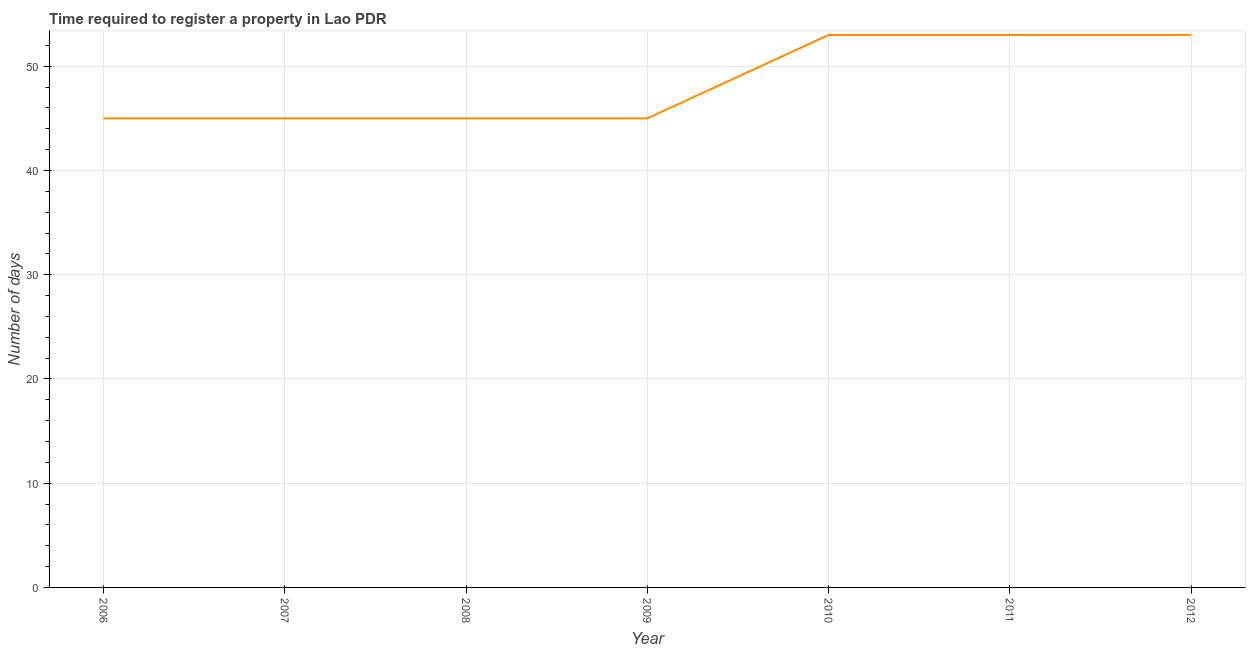What is the number of days required to register property in 2010?
Provide a succinct answer. 53. Across all years, what is the maximum number of days required to register property?
Give a very brief answer. 53. Across all years, what is the minimum number of days required to register property?
Provide a short and direct response. 45. In which year was the number of days required to register property minimum?
Provide a short and direct response. 2006. What is the sum of the number of days required to register property?
Provide a succinct answer. 339. What is the difference between the number of days required to register property in 2007 and 2012?
Your answer should be compact. -8. What is the average number of days required to register property per year?
Give a very brief answer. 48.43. What is the median number of days required to register property?
Provide a short and direct response. 45. In how many years, is the number of days required to register property greater than 48 days?
Make the answer very short. 3. What is the ratio of the number of days required to register property in 2006 to that in 2009?
Keep it short and to the point. 1. Is the difference between the number of days required to register property in 2007 and 2010 greater than the difference between any two years?
Ensure brevity in your answer.  Yes. What is the difference between the highest and the second highest number of days required to register property?
Your answer should be very brief. 0. Is the sum of the number of days required to register property in 2007 and 2008 greater than the maximum number of days required to register property across all years?
Offer a very short reply. Yes. What is the difference between the highest and the lowest number of days required to register property?
Keep it short and to the point. 8. In how many years, is the number of days required to register property greater than the average number of days required to register property taken over all years?
Your response must be concise. 3. Does the number of days required to register property monotonically increase over the years?
Ensure brevity in your answer.  No. What is the difference between two consecutive major ticks on the Y-axis?
Your response must be concise. 10. Are the values on the major ticks of Y-axis written in scientific E-notation?
Your response must be concise. No. Does the graph contain any zero values?
Provide a succinct answer. No. What is the title of the graph?
Offer a very short reply. Time required to register a property in Lao PDR. What is the label or title of the Y-axis?
Keep it short and to the point. Number of days. What is the Number of days of 2007?
Your answer should be compact. 45. What is the Number of days of 2010?
Provide a short and direct response. 53. What is the Number of days of 2011?
Offer a very short reply. 53. What is the difference between the Number of days in 2006 and 2010?
Your response must be concise. -8. What is the difference between the Number of days in 2006 and 2011?
Give a very brief answer. -8. What is the difference between the Number of days in 2007 and 2008?
Ensure brevity in your answer.  0. What is the difference between the Number of days in 2008 and 2009?
Keep it short and to the point. 0. What is the difference between the Number of days in 2008 and 2011?
Your answer should be very brief. -8. What is the difference between the Number of days in 2008 and 2012?
Keep it short and to the point. -8. What is the difference between the Number of days in 2010 and 2012?
Provide a short and direct response. 0. What is the difference between the Number of days in 2011 and 2012?
Give a very brief answer. 0. What is the ratio of the Number of days in 2006 to that in 2007?
Ensure brevity in your answer.  1. What is the ratio of the Number of days in 2006 to that in 2008?
Give a very brief answer. 1. What is the ratio of the Number of days in 2006 to that in 2009?
Offer a very short reply. 1. What is the ratio of the Number of days in 2006 to that in 2010?
Offer a terse response. 0.85. What is the ratio of the Number of days in 2006 to that in 2011?
Provide a succinct answer. 0.85. What is the ratio of the Number of days in 2006 to that in 2012?
Your answer should be very brief. 0.85. What is the ratio of the Number of days in 2007 to that in 2008?
Your answer should be compact. 1. What is the ratio of the Number of days in 2007 to that in 2010?
Your answer should be compact. 0.85. What is the ratio of the Number of days in 2007 to that in 2011?
Your response must be concise. 0.85. What is the ratio of the Number of days in 2007 to that in 2012?
Provide a succinct answer. 0.85. What is the ratio of the Number of days in 2008 to that in 2010?
Your response must be concise. 0.85. What is the ratio of the Number of days in 2008 to that in 2011?
Offer a very short reply. 0.85. What is the ratio of the Number of days in 2008 to that in 2012?
Your answer should be compact. 0.85. What is the ratio of the Number of days in 2009 to that in 2010?
Give a very brief answer. 0.85. What is the ratio of the Number of days in 2009 to that in 2011?
Provide a short and direct response. 0.85. What is the ratio of the Number of days in 2009 to that in 2012?
Make the answer very short. 0.85. What is the ratio of the Number of days in 2011 to that in 2012?
Ensure brevity in your answer.  1. 